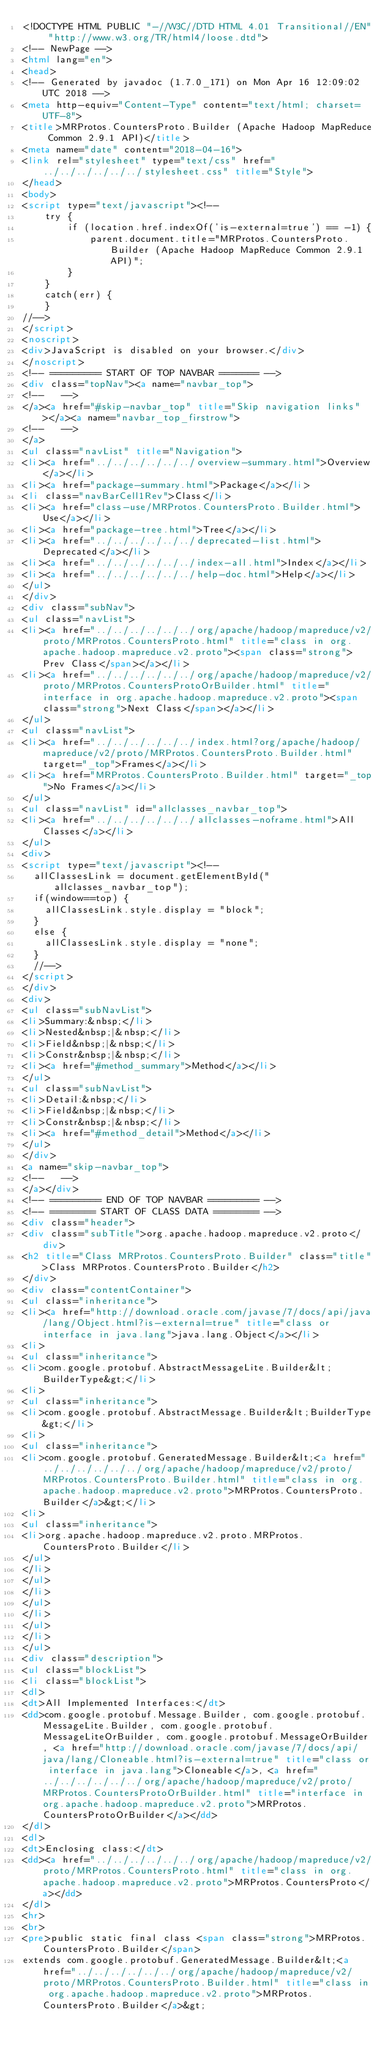<code> <loc_0><loc_0><loc_500><loc_500><_HTML_><!DOCTYPE HTML PUBLIC "-//W3C//DTD HTML 4.01 Transitional//EN" "http://www.w3.org/TR/html4/loose.dtd">
<!-- NewPage -->
<html lang="en">
<head>
<!-- Generated by javadoc (1.7.0_171) on Mon Apr 16 12:09:02 UTC 2018 -->
<meta http-equiv="Content-Type" content="text/html; charset=UTF-8">
<title>MRProtos.CountersProto.Builder (Apache Hadoop MapReduce Common 2.9.1 API)</title>
<meta name="date" content="2018-04-16">
<link rel="stylesheet" type="text/css" href="../../../../../../stylesheet.css" title="Style">
</head>
<body>
<script type="text/javascript"><!--
    try {
        if (location.href.indexOf('is-external=true') == -1) {
            parent.document.title="MRProtos.CountersProto.Builder (Apache Hadoop MapReduce Common 2.9.1 API)";
        }
    }
    catch(err) {
    }
//-->
</script>
<noscript>
<div>JavaScript is disabled on your browser.</div>
</noscript>
<!-- ========= START OF TOP NAVBAR ======= -->
<div class="topNav"><a name="navbar_top">
<!--   -->
</a><a href="#skip-navbar_top" title="Skip navigation links"></a><a name="navbar_top_firstrow">
<!--   -->
</a>
<ul class="navList" title="Navigation">
<li><a href="../../../../../../overview-summary.html">Overview</a></li>
<li><a href="package-summary.html">Package</a></li>
<li class="navBarCell1Rev">Class</li>
<li><a href="class-use/MRProtos.CountersProto.Builder.html">Use</a></li>
<li><a href="package-tree.html">Tree</a></li>
<li><a href="../../../../../../deprecated-list.html">Deprecated</a></li>
<li><a href="../../../../../../index-all.html">Index</a></li>
<li><a href="../../../../../../help-doc.html">Help</a></li>
</ul>
</div>
<div class="subNav">
<ul class="navList">
<li><a href="../../../../../../org/apache/hadoop/mapreduce/v2/proto/MRProtos.CountersProto.html" title="class in org.apache.hadoop.mapreduce.v2.proto"><span class="strong">Prev Class</span></a></li>
<li><a href="../../../../../../org/apache/hadoop/mapreduce/v2/proto/MRProtos.CountersProtoOrBuilder.html" title="interface in org.apache.hadoop.mapreduce.v2.proto"><span class="strong">Next Class</span></a></li>
</ul>
<ul class="navList">
<li><a href="../../../../../../index.html?org/apache/hadoop/mapreduce/v2/proto/MRProtos.CountersProto.Builder.html" target="_top">Frames</a></li>
<li><a href="MRProtos.CountersProto.Builder.html" target="_top">No Frames</a></li>
</ul>
<ul class="navList" id="allclasses_navbar_top">
<li><a href="../../../../../../allclasses-noframe.html">All Classes</a></li>
</ul>
<div>
<script type="text/javascript"><!--
  allClassesLink = document.getElementById("allclasses_navbar_top");
  if(window==top) {
    allClassesLink.style.display = "block";
  }
  else {
    allClassesLink.style.display = "none";
  }
  //-->
</script>
</div>
<div>
<ul class="subNavList">
<li>Summary:&nbsp;</li>
<li>Nested&nbsp;|&nbsp;</li>
<li>Field&nbsp;|&nbsp;</li>
<li>Constr&nbsp;|&nbsp;</li>
<li><a href="#method_summary">Method</a></li>
</ul>
<ul class="subNavList">
<li>Detail:&nbsp;</li>
<li>Field&nbsp;|&nbsp;</li>
<li>Constr&nbsp;|&nbsp;</li>
<li><a href="#method_detail">Method</a></li>
</ul>
</div>
<a name="skip-navbar_top">
<!--   -->
</a></div>
<!-- ========= END OF TOP NAVBAR ========= -->
<!-- ======== START OF CLASS DATA ======== -->
<div class="header">
<div class="subTitle">org.apache.hadoop.mapreduce.v2.proto</div>
<h2 title="Class MRProtos.CountersProto.Builder" class="title">Class MRProtos.CountersProto.Builder</h2>
</div>
<div class="contentContainer">
<ul class="inheritance">
<li><a href="http://download.oracle.com/javase/7/docs/api/java/lang/Object.html?is-external=true" title="class or interface in java.lang">java.lang.Object</a></li>
<li>
<ul class="inheritance">
<li>com.google.protobuf.AbstractMessageLite.Builder&lt;BuilderType&gt;</li>
<li>
<ul class="inheritance">
<li>com.google.protobuf.AbstractMessage.Builder&lt;BuilderType&gt;</li>
<li>
<ul class="inheritance">
<li>com.google.protobuf.GeneratedMessage.Builder&lt;<a href="../../../../../../org/apache/hadoop/mapreduce/v2/proto/MRProtos.CountersProto.Builder.html" title="class in org.apache.hadoop.mapreduce.v2.proto">MRProtos.CountersProto.Builder</a>&gt;</li>
<li>
<ul class="inheritance">
<li>org.apache.hadoop.mapreduce.v2.proto.MRProtos.CountersProto.Builder</li>
</ul>
</li>
</ul>
</li>
</ul>
</li>
</ul>
</li>
</ul>
<div class="description">
<ul class="blockList">
<li class="blockList">
<dl>
<dt>All Implemented Interfaces:</dt>
<dd>com.google.protobuf.Message.Builder, com.google.protobuf.MessageLite.Builder, com.google.protobuf.MessageLiteOrBuilder, com.google.protobuf.MessageOrBuilder, <a href="http://download.oracle.com/javase/7/docs/api/java/lang/Cloneable.html?is-external=true" title="class or interface in java.lang">Cloneable</a>, <a href="../../../../../../org/apache/hadoop/mapreduce/v2/proto/MRProtos.CountersProtoOrBuilder.html" title="interface in org.apache.hadoop.mapreduce.v2.proto">MRProtos.CountersProtoOrBuilder</a></dd>
</dl>
<dl>
<dt>Enclosing class:</dt>
<dd><a href="../../../../../../org/apache/hadoop/mapreduce/v2/proto/MRProtos.CountersProto.html" title="class in org.apache.hadoop.mapreduce.v2.proto">MRProtos.CountersProto</a></dd>
</dl>
<hr>
<br>
<pre>public static final class <span class="strong">MRProtos.CountersProto.Builder</span>
extends com.google.protobuf.GeneratedMessage.Builder&lt;<a href="../../../../../../org/apache/hadoop/mapreduce/v2/proto/MRProtos.CountersProto.Builder.html" title="class in org.apache.hadoop.mapreduce.v2.proto">MRProtos.CountersProto.Builder</a>&gt;</code> 